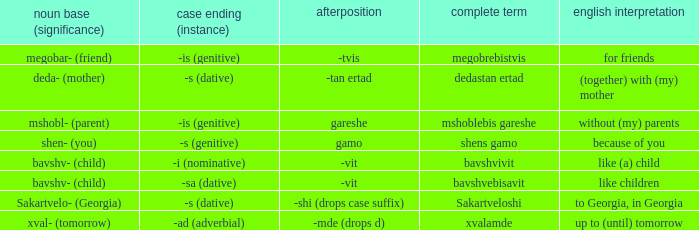What is English Meaning, when Case Suffix (Case) is "-sa (dative)"? Like children. 